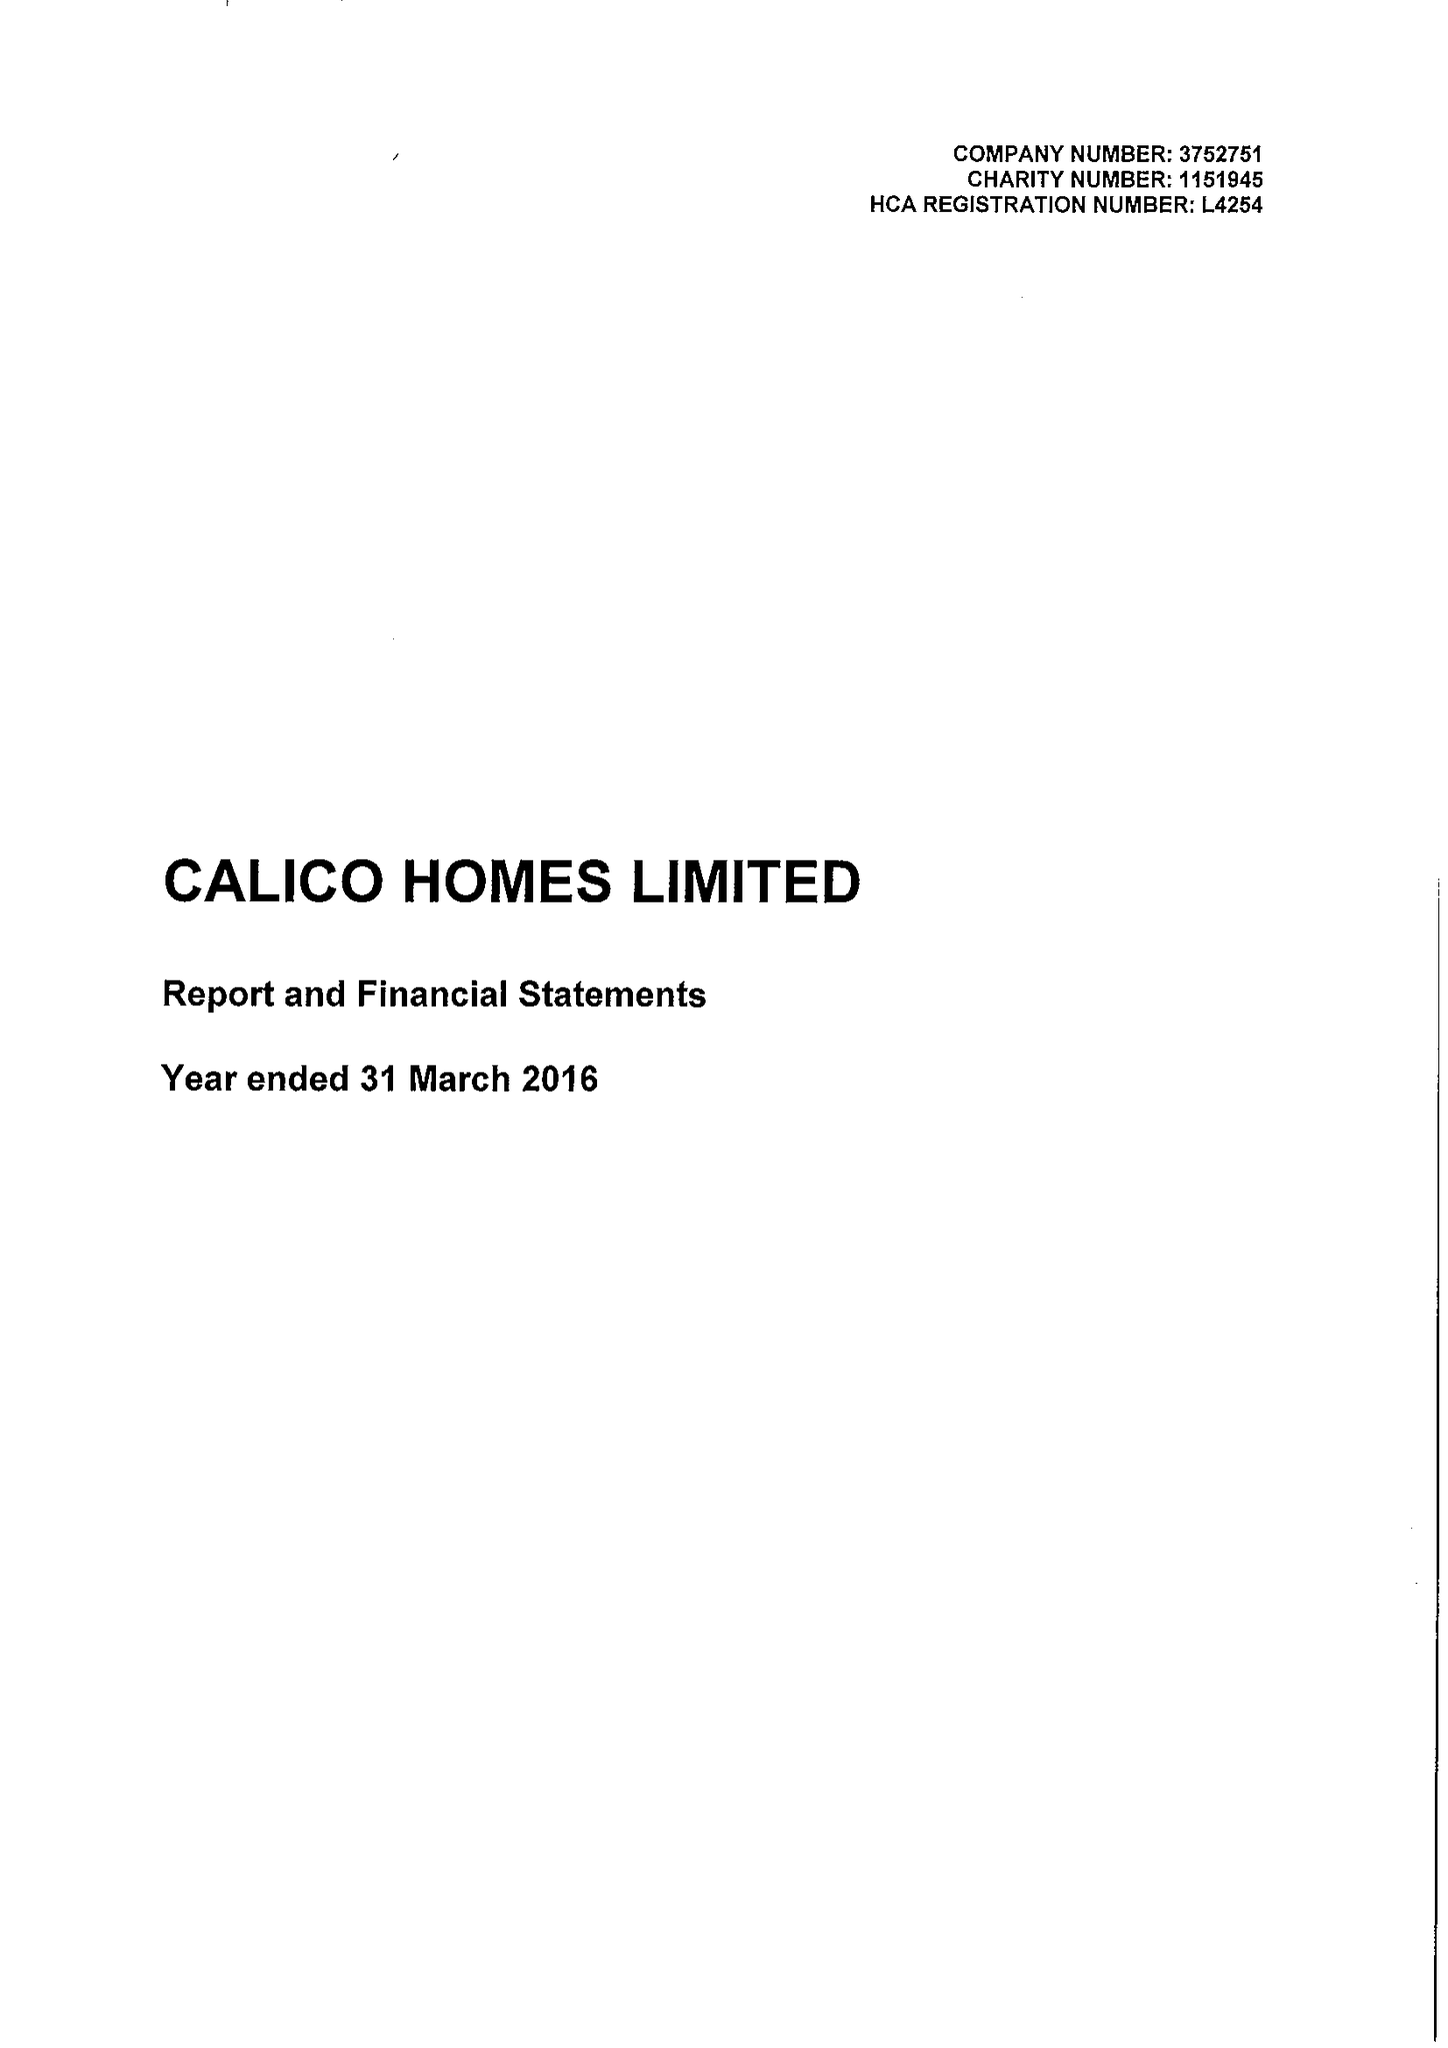What is the value for the spending_annually_in_british_pounds?
Answer the question using a single word or phrase. 22693000.00 